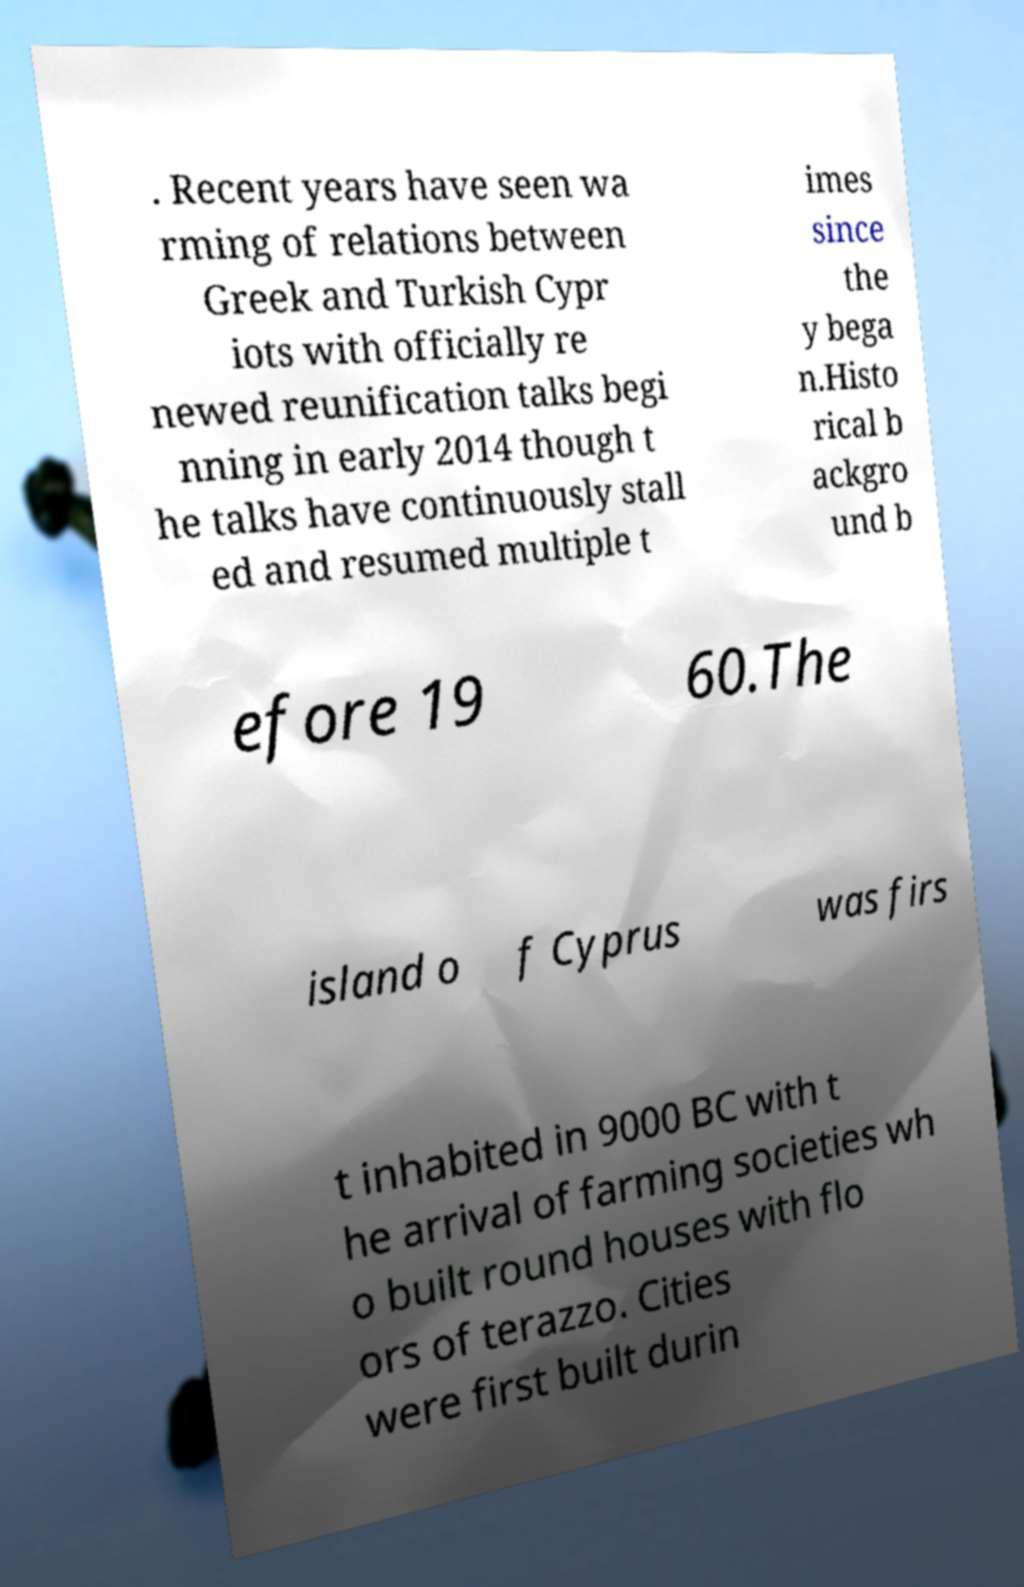Could you assist in decoding the text presented in this image and type it out clearly? . Recent years have seen wa rming of relations between Greek and Turkish Cypr iots with officially re newed reunification talks begi nning in early 2014 though t he talks have continuously stall ed and resumed multiple t imes since the y bega n.Histo rical b ackgro und b efore 19 60.The island o f Cyprus was firs t inhabited in 9000 BC with t he arrival of farming societies wh o built round houses with flo ors of terazzo. Cities were first built durin 